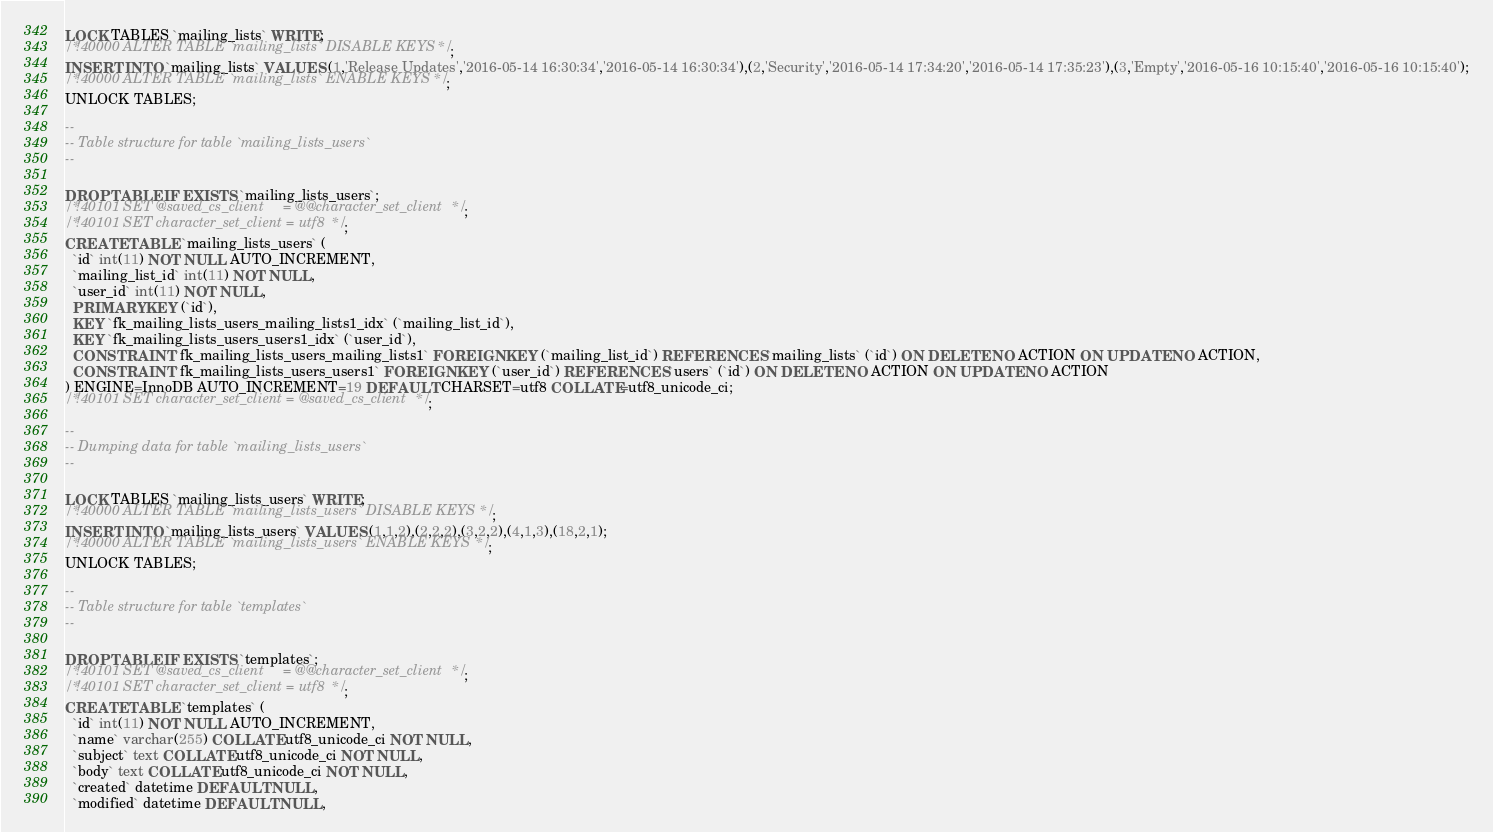Convert code to text. <code><loc_0><loc_0><loc_500><loc_500><_SQL_>LOCK TABLES `mailing_lists` WRITE;
/*!40000 ALTER TABLE `mailing_lists` DISABLE KEYS */;
INSERT INTO `mailing_lists` VALUES (1,'Release Updates','2016-05-14 16:30:34','2016-05-14 16:30:34'),(2,'Security','2016-05-14 17:34:20','2016-05-14 17:35:23'),(3,'Empty','2016-05-16 10:15:40','2016-05-16 10:15:40');
/*!40000 ALTER TABLE `mailing_lists` ENABLE KEYS */;
UNLOCK TABLES;

--
-- Table structure for table `mailing_lists_users`
--

DROP TABLE IF EXISTS `mailing_lists_users`;
/*!40101 SET @saved_cs_client     = @@character_set_client */;
/*!40101 SET character_set_client = utf8 */;
CREATE TABLE `mailing_lists_users` (
  `id` int(11) NOT NULL AUTO_INCREMENT,
  `mailing_list_id` int(11) NOT NULL,
  `user_id` int(11) NOT NULL,
  PRIMARY KEY (`id`),
  KEY `fk_mailing_lists_users_mailing_lists1_idx` (`mailing_list_id`),
  KEY `fk_mailing_lists_users_users1_idx` (`user_id`),
  CONSTRAINT `fk_mailing_lists_users_mailing_lists1` FOREIGN KEY (`mailing_list_id`) REFERENCES `mailing_lists` (`id`) ON DELETE NO ACTION ON UPDATE NO ACTION,
  CONSTRAINT `fk_mailing_lists_users_users1` FOREIGN KEY (`user_id`) REFERENCES `users` (`id`) ON DELETE NO ACTION ON UPDATE NO ACTION
) ENGINE=InnoDB AUTO_INCREMENT=19 DEFAULT CHARSET=utf8 COLLATE=utf8_unicode_ci;
/*!40101 SET character_set_client = @saved_cs_client */;

--
-- Dumping data for table `mailing_lists_users`
--

LOCK TABLES `mailing_lists_users` WRITE;
/*!40000 ALTER TABLE `mailing_lists_users` DISABLE KEYS */;
INSERT INTO `mailing_lists_users` VALUES (1,1,2),(2,2,2),(3,2,2),(4,1,3),(18,2,1);
/*!40000 ALTER TABLE `mailing_lists_users` ENABLE KEYS */;
UNLOCK TABLES;

--
-- Table structure for table `templates`
--

DROP TABLE IF EXISTS `templates`;
/*!40101 SET @saved_cs_client     = @@character_set_client */;
/*!40101 SET character_set_client = utf8 */;
CREATE TABLE `templates` (
  `id` int(11) NOT NULL AUTO_INCREMENT,
  `name` varchar(255) COLLATE utf8_unicode_ci NOT NULL,
  `subject` text COLLATE utf8_unicode_ci NOT NULL,
  `body` text COLLATE utf8_unicode_ci NOT NULL,
  `created` datetime DEFAULT NULL,
  `modified` datetime DEFAULT NULL,</code> 